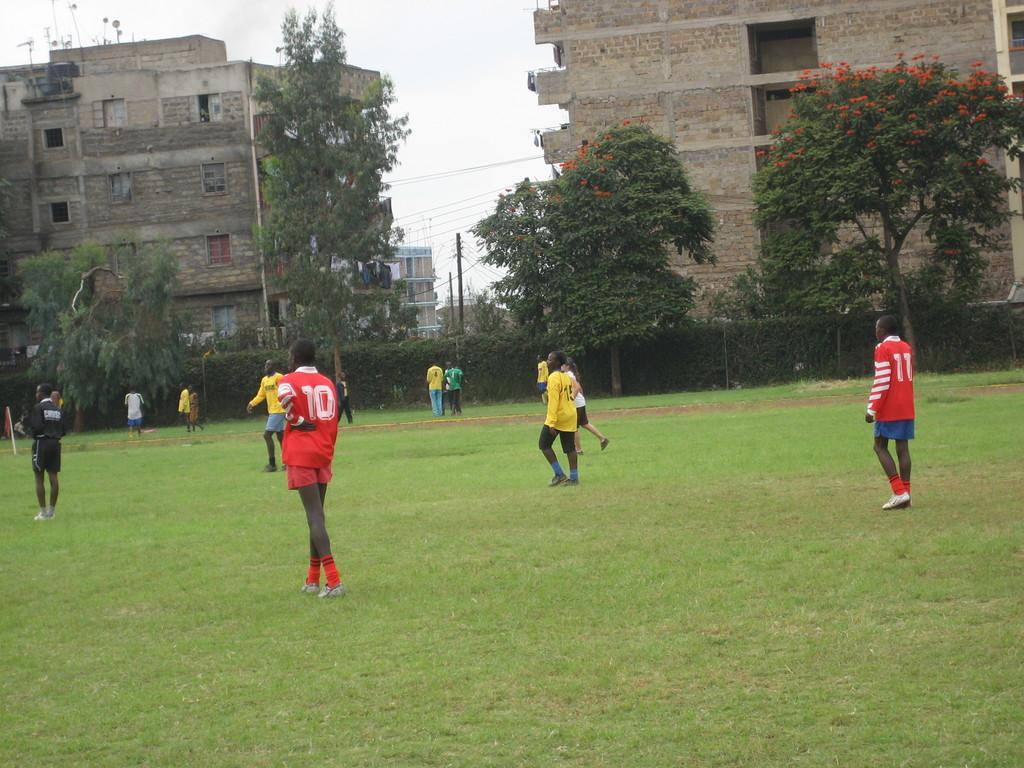Can you describe this image briefly? In this picture we can see few people are playing on the grass, around we can see fencing, trees and buildings. 